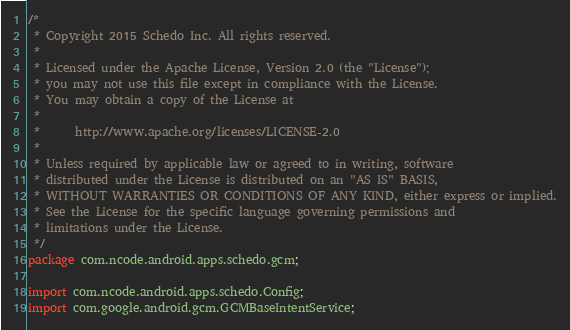<code> <loc_0><loc_0><loc_500><loc_500><_Java_>/*
 * Copyright 2015 Schedo Inc. All rights reserved.
 *
 * Licensed under the Apache License, Version 2.0 (the "License");
 * you may not use this file except in compliance with the License.
 * You may obtain a copy of the License at
 *
 *      http://www.apache.org/licenses/LICENSE-2.0
 *
 * Unless required by applicable law or agreed to in writing, software
 * distributed under the License is distributed on an "AS IS" BASIS,
 * WITHOUT WARRANTIES OR CONDITIONS OF ANY KIND, either express or implied.
 * See the License for the specific language governing permissions and
 * limitations under the License.
 */
package com.ncode.android.apps.schedo.gcm;

import com.ncode.android.apps.schedo.Config;
import com.google.android.gcm.GCMBaseIntentService;</code> 